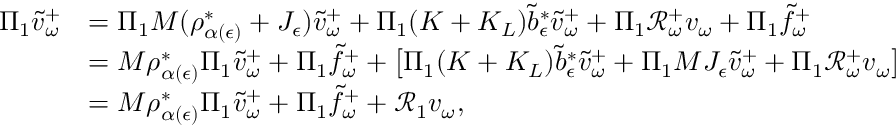Convert formula to latex. <formula><loc_0><loc_0><loc_500><loc_500>\begin{array} { r l } { \Pi _ { 1 } \tilde { v } _ { \omega } ^ { + } } & { = \Pi _ { 1 } M ( \rho _ { \alpha ( \epsilon ) } ^ { * } + J _ { \epsilon } ) \tilde { v } _ { \omega } ^ { + } + \Pi _ { 1 } ( K + K _ { L } ) \tilde { b } _ { \epsilon } ^ { * } \tilde { v } _ { \omega } ^ { + } + \Pi _ { 1 } \mathcal { R } _ { \omega } ^ { + } v _ { \omega } + \Pi _ { 1 } \tilde { f } _ { \omega } ^ { + } } \\ & { = M \rho _ { \alpha ( \epsilon ) } ^ { * } \Pi _ { 1 } \tilde { v } _ { \omega } ^ { + } + \Pi _ { 1 } \tilde { f } _ { \omega } ^ { + } + \left [ \Pi _ { 1 } ( K + K _ { L } ) \tilde { b } _ { \epsilon } ^ { * } \tilde { v } _ { \omega } ^ { + } + \Pi _ { 1 } M J _ { \epsilon } \tilde { v } _ { \omega } ^ { + } + \Pi _ { 1 } \mathcal { R } _ { \omega } ^ { + } v _ { \omega } \right ] } \\ & { = M \rho _ { \alpha ( \epsilon ) } ^ { * } \Pi _ { 1 } \tilde { v } _ { \omega } ^ { + } + \Pi _ { 1 } \tilde { f } _ { \omega } ^ { + } + \mathcal { R } _ { 1 } v _ { \omega } , } \end{array}</formula> 